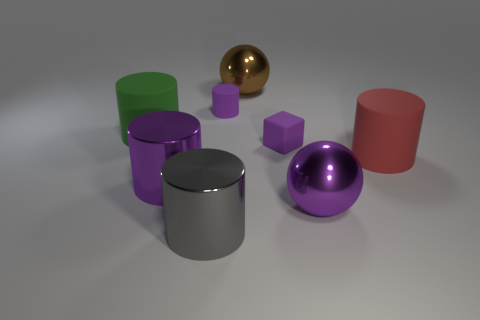Subtract all green cylinders. How many cylinders are left? 4 Subtract all gray metallic cylinders. How many cylinders are left? 4 Subtract 1 cylinders. How many cylinders are left? 4 Subtract all brown cylinders. Subtract all blue spheres. How many cylinders are left? 5 Add 1 large red things. How many objects exist? 9 Subtract all spheres. How many objects are left? 6 Subtract all large rubber things. Subtract all tiny cyan rubber cylinders. How many objects are left? 6 Add 7 big gray metallic things. How many big gray metallic things are left? 8 Add 8 brown spheres. How many brown spheres exist? 9 Subtract 0 yellow cylinders. How many objects are left? 8 